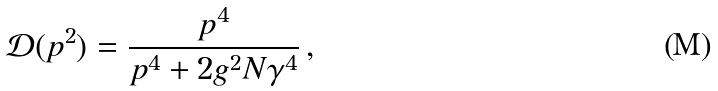Convert formula to latex. <formula><loc_0><loc_0><loc_500><loc_500>\mathcal { D } ( p ^ { 2 } ) = \frac { p ^ { 4 } } { p ^ { 4 } + 2 g ^ { 2 } N \gamma ^ { 4 } } \, ,</formula> 